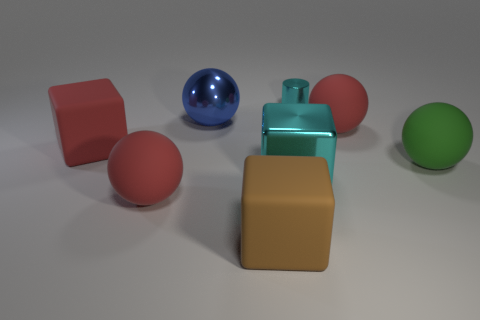The thing that is both behind the big red rubber cube and left of the tiny shiny cylinder is made of what material?
Keep it short and to the point. Metal. Are the red sphere that is to the left of the tiny cyan metallic thing and the green object made of the same material?
Your answer should be compact. Yes. What material is the green ball?
Your response must be concise. Rubber. What size is the cyan thing that is left of the tiny metal cylinder?
Give a very brief answer. Large. Is there any other thing of the same color as the cylinder?
Provide a succinct answer. Yes. There is a matte object on the right side of the large rubber thing that is behind the big red block; are there any big brown objects behind it?
Your answer should be compact. No. There is a metal object in front of the green sphere; does it have the same color as the tiny object?
Provide a succinct answer. Yes. What number of blocks are shiny objects or big red things?
Provide a short and direct response. 2. There is a cyan thing that is behind the red ball to the right of the brown block; what is its shape?
Keep it short and to the point. Cylinder. There is a matte block left of the large sphere behind the red matte object that is on the right side of the small cylinder; what size is it?
Offer a very short reply. Large. 